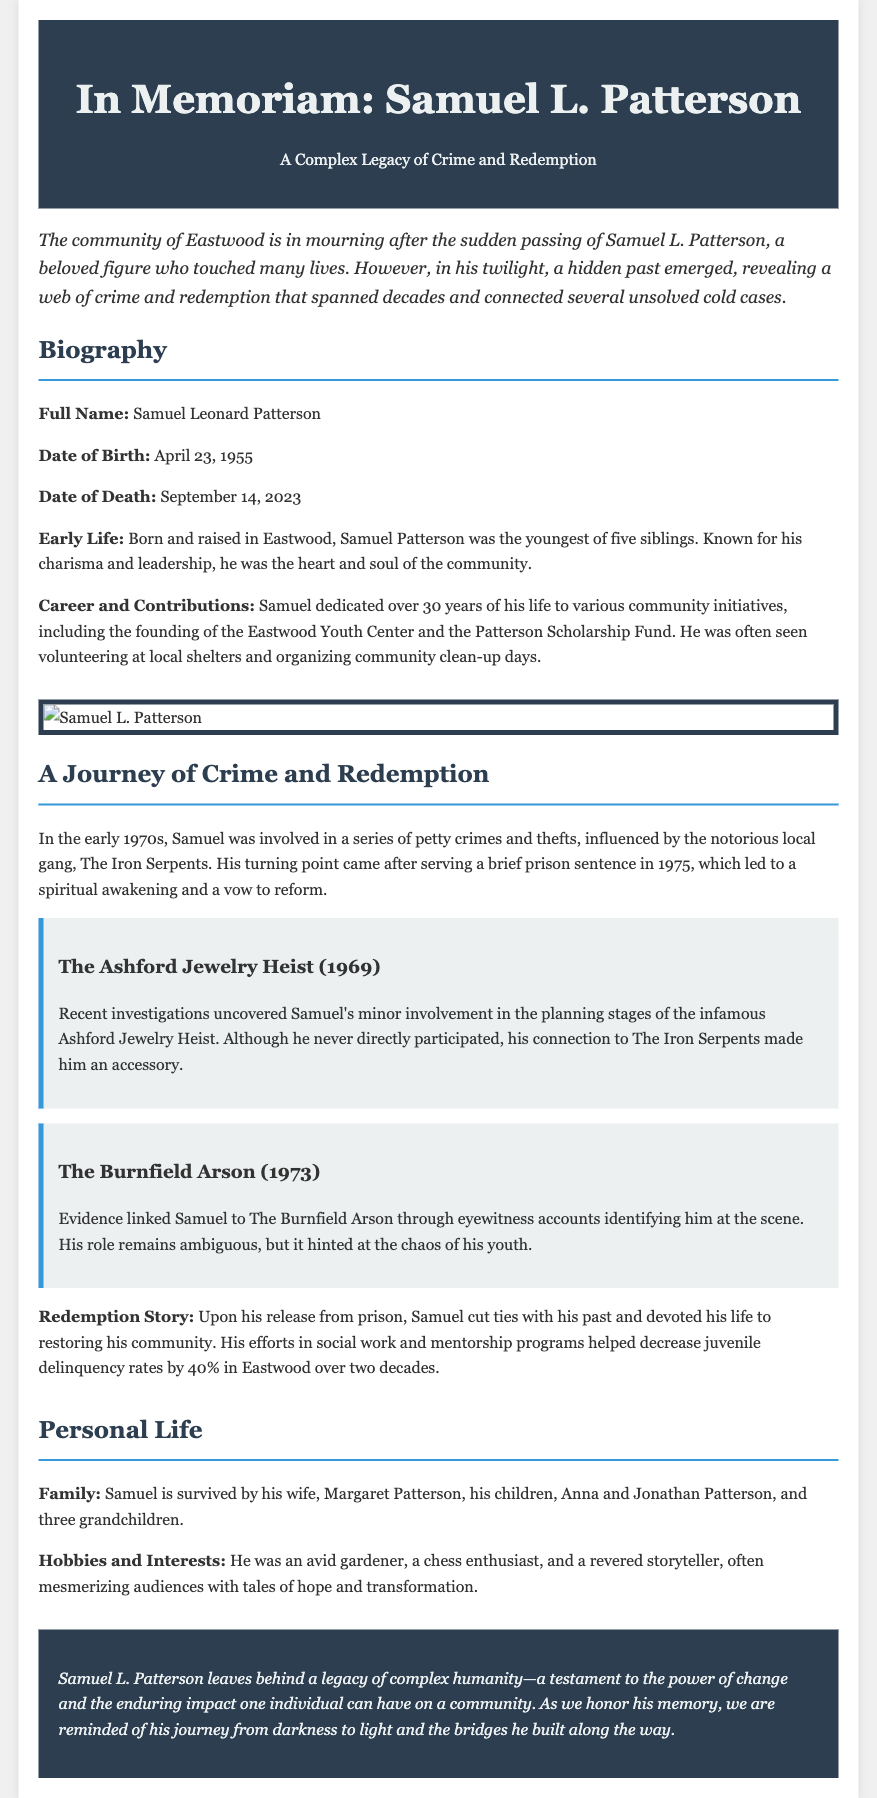what is the full name of the deceased? The full name of the deceased is provided in the document as Samuel Leonard Patterson.
Answer: Samuel Leonard Patterson when was Samuel L. Patterson born? The document specifies that he was born on April 23, 1955.
Answer: April 23, 1955 what major community initiative did Samuel founder? The document mentions that he founded the Eastwood Youth Center.
Answer: Eastwood Youth Center which criminal gang was Samuel associated with in the 1970s? The document states that he was influenced by the notorious local gang called The Iron Serpents.
Answer: The Iron Serpents what was Samuel's profession after his prison sentence? The document indicates he devoted his life to social work and mentorship programs.
Answer: social work and mentorship programs how much did juvenile delinquency rates decrease due to his efforts? The document notes that juvenile delinquency rates decreased by 40% in Eastwood.
Answer: 40% what crime is linked to Samuel in the document? The document connects him to the Ashford Jewelry Heist and The Burnfield Arson.
Answer: Ashford Jewelry Heist and The Burnfield Arson who survives Samuel L. Patterson? The document lists his wife, children, and grandchildren as survivors.
Answer: wife, children, and grandchildren what kind of legacy did Samuel leave behind? The document describes his legacy as one of complex humanity and the power of change.
Answer: complex humanity and the power of change 